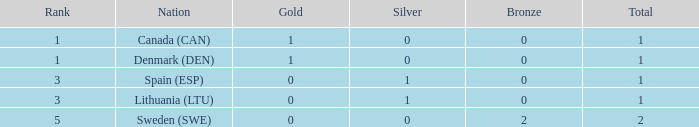What is the total when there were less than 0 bronze? 0.0. 